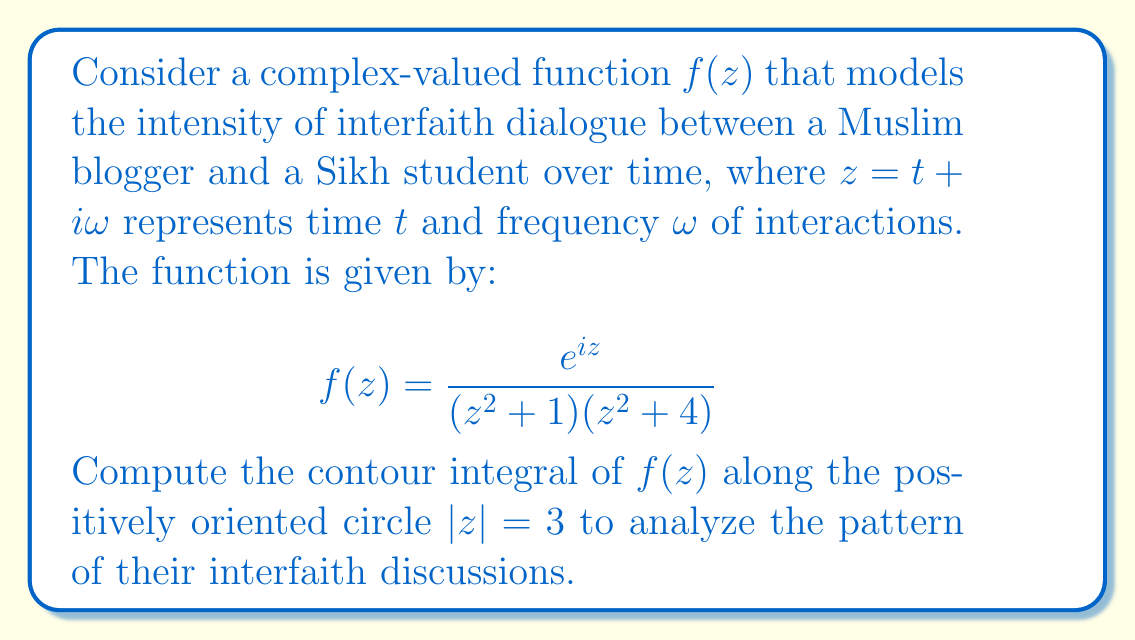Can you solve this math problem? To solve this problem, we'll use the Residue Theorem. The steps are as follows:

1) First, we need to identify the singularities of $f(z)$ inside the contour $|z| = 3$. The poles are at:
   $z = \pm i$ (from $z^2 + 1 = 0$)
   $z = \pm 2i$ (from $z^2 + 4 = 0$)
   
   Only $z = \pm i$ lie inside the contour.

2) Calculate the residues at these poles:

   At $z = i$:
   $$\text{Res}(f, i) = \lim_{z \to i} (z-i) \frac{e^{iz}}{(z^2 + 1)(z^2 + 4)}$$
   $$= \lim_{z \to i} \frac{e^{iz}}{(z+i)(z^2 + 4)} = \frac{e^{-1}}{2i(i^2 + 4)} = \frac{e^{-1}}{6i}$$

   At $z = -i$:
   $$\text{Res}(f, -i) = \lim_{z \to -i} (z+i) \frac{e^{iz}}{(z^2 + 1)(z^2 + 4)}$$
   $$= \lim_{z \to -i} \frac{e^{iz}}{(z-i)(z^2 + 4)} = \frac{e^1}{-2i((-i)^2 + 4)} = -\frac{e}{6i}$$

3) Apply the Residue Theorem:
   $$\oint_{|z|=3} f(z) dz = 2\pi i \sum \text{Res}(f, a_k)$$
   where $a_k$ are the poles inside the contour.

   $$\oint_{|z|=3} f(z) dz = 2\pi i \left(\frac{e^{-1}}{6i} - \frac{e}{6i}\right)$$

4) Simplify:
   $$= 2\pi i \cdot \frac{e^{-1} - e}{6i} = \frac{\pi}{3}(e^{-1} - e)$$

This result represents the net intensity of interfaith dialogue over a complete cycle of interactions.
Answer: $$\frac{\pi}{3}(e^{-1} - e)$$ 